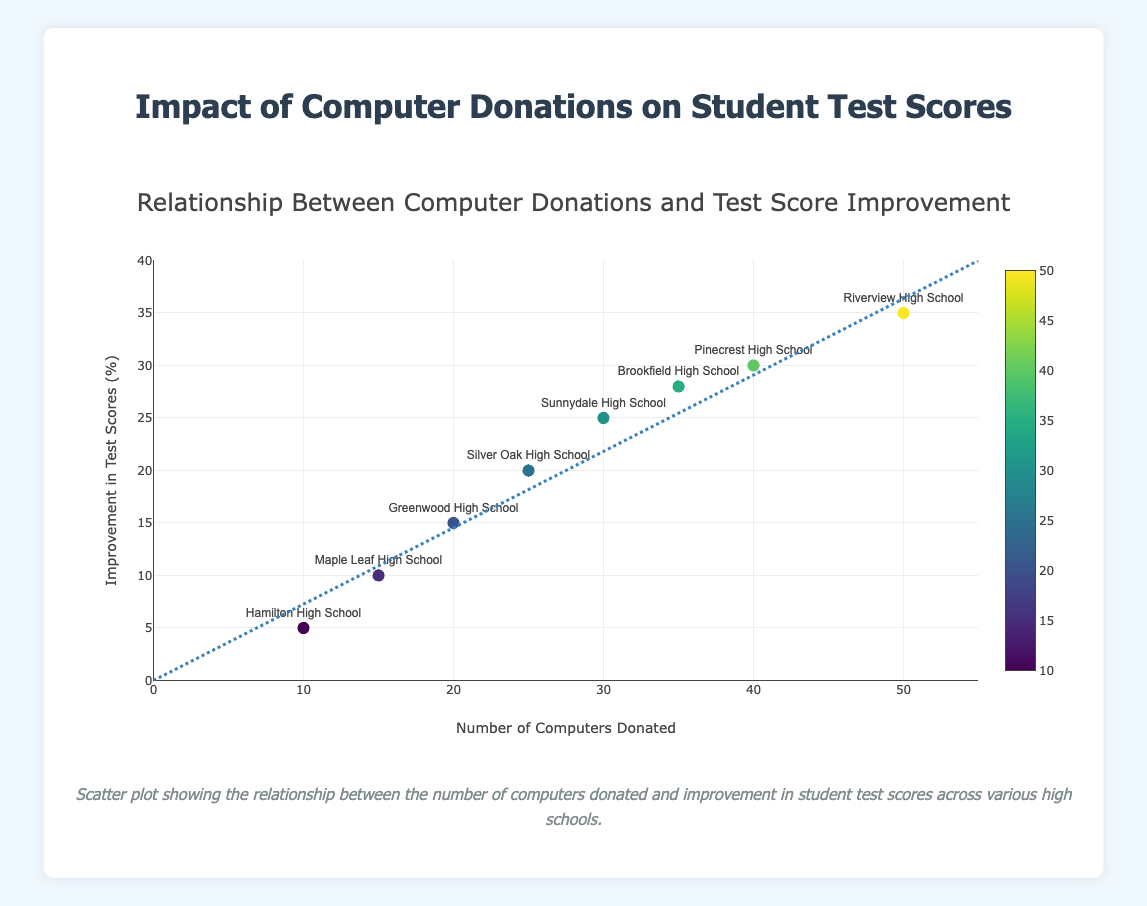What is the title of the scatter plot? The title can be found at the top of the scatter plot. It provides an overview of what the plot is about.
Answer: Relationship Between Computer Donations and Test Score Improvement What are the axis titles in the scatter plot? Look at the titles along the x-axis and y-axis, which describe what each axis is measuring. The x-axis title is "Number of Computers Donated" and the y-axis title is "Improvement in Test Scores (%)".
Answer: Number of Computers Donated and Improvement in Test Scores (%) Which school received the highest number of computer donations, and what was the corresponding improvement in their test scores? Identify the data point with the largest x-value, which represents the highest number of computers donated, and then note the corresponding y-value. Riverview High School received 50 computers, and the improvement in test scores is 35%.
Answer: Riverview High School, 35% How many data points are there in the scatter plot? Count each marker in the scatter plot to determine the total number of schools/data points.
Answer: 8 Which school showed the least improvement in test scores despite receiving computer donations, and how many computers were donated to them? Identify the data point with the smallest y-value, which represents the least improvement in test scores, and then note the x-value, which represents the number of computers donated. Hamilton High School had the smallest improvement in test scores at 5%, and they received 10 computers.
Answer: Hamilton High School, 10 Is there a trend between the number of computers donated and the improvement in test scores? Look at the trend line drawn on the scatter plot. If it goes upward from left to right, it shows a positive trend; if downward, it shows a negative trend. The trend line is positively sloped, indicating that more computers donated generally correspond to higher improvements in test scores.
Answer: Positive trend Which schools showed an improvement in test scores that was exactly 10%? Identify the data point(s) with a y-value of 10%. Maple Leaf High School showed an improvement in test scores of 10%.
Answer: Maple Leaf High School Calculate the average number of computers donated across all the schools. To find the average, add up all the number of computers donated and divide by the total number of schools: (20 + 30 + 10 + 50 + 25 + 40 + 15 + 35) / 8.  The sum is 225, and the average is 225 / 8 = 28.125.
Answer: 28.125 Which two schools received the closest number of computer donations, and what is the difference? Compare the number of computers donated at each school and identify the two with the smallest difference between their numbers. Greenwood High School and Silver Oak High School received 20 and 25 computers, respectively, with a difference of 5 computers.
Answer: Greenwood High School and Silver Oak High School, 5 